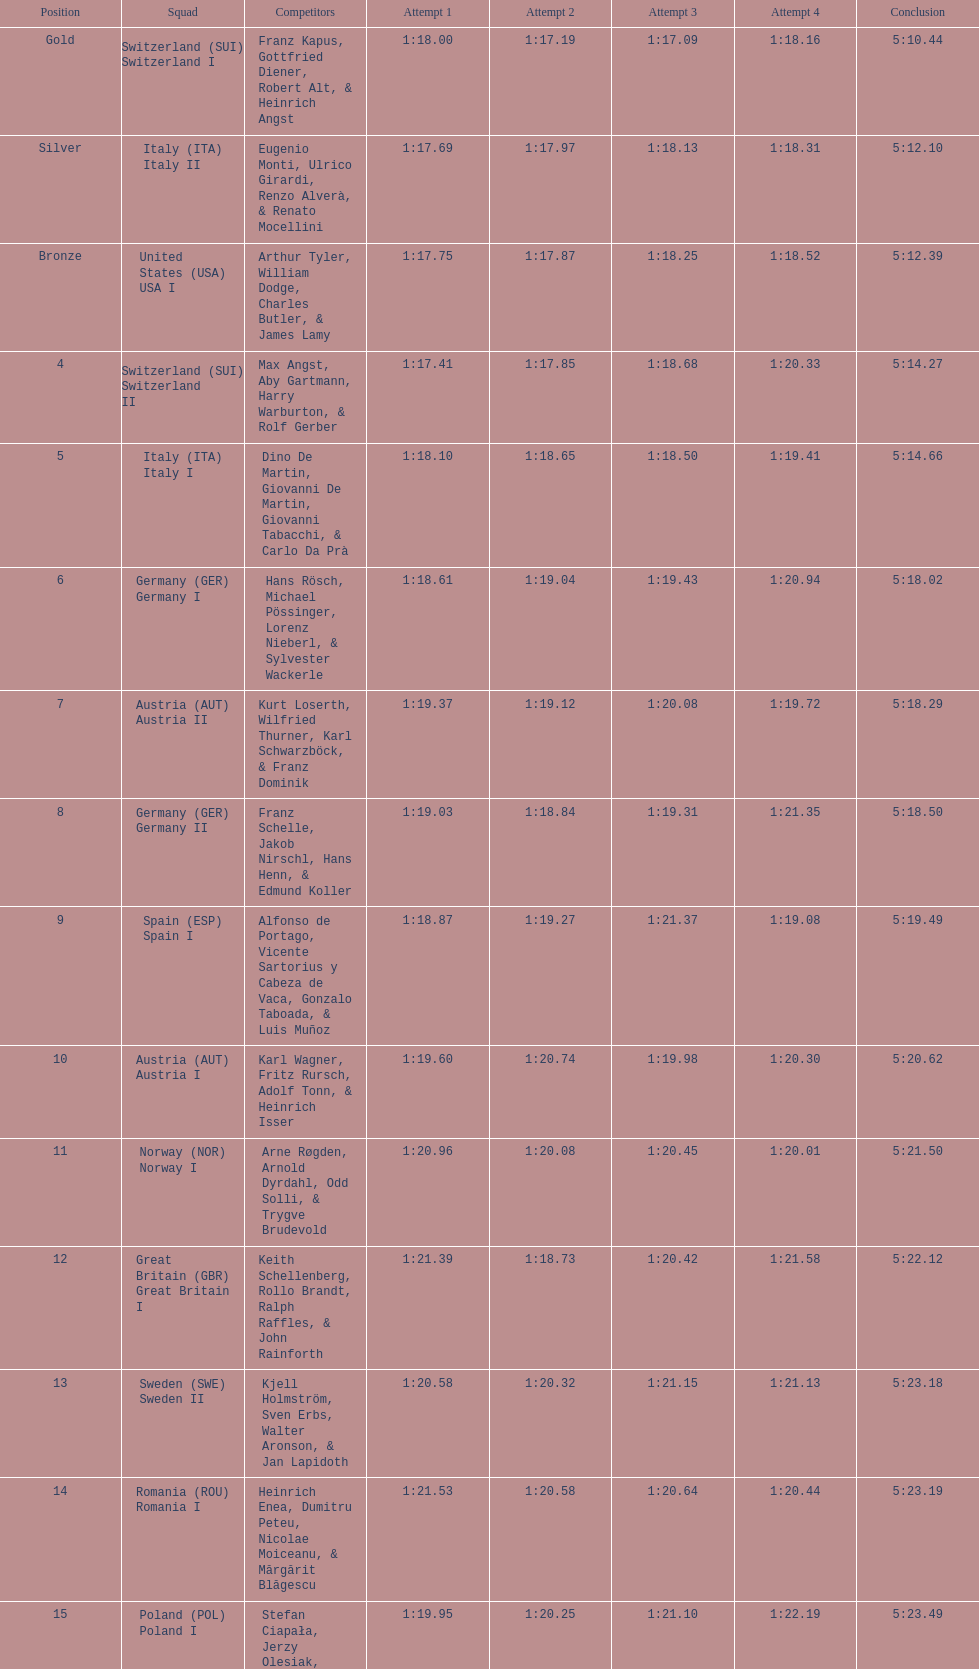How many squads did germany possess? 2. 